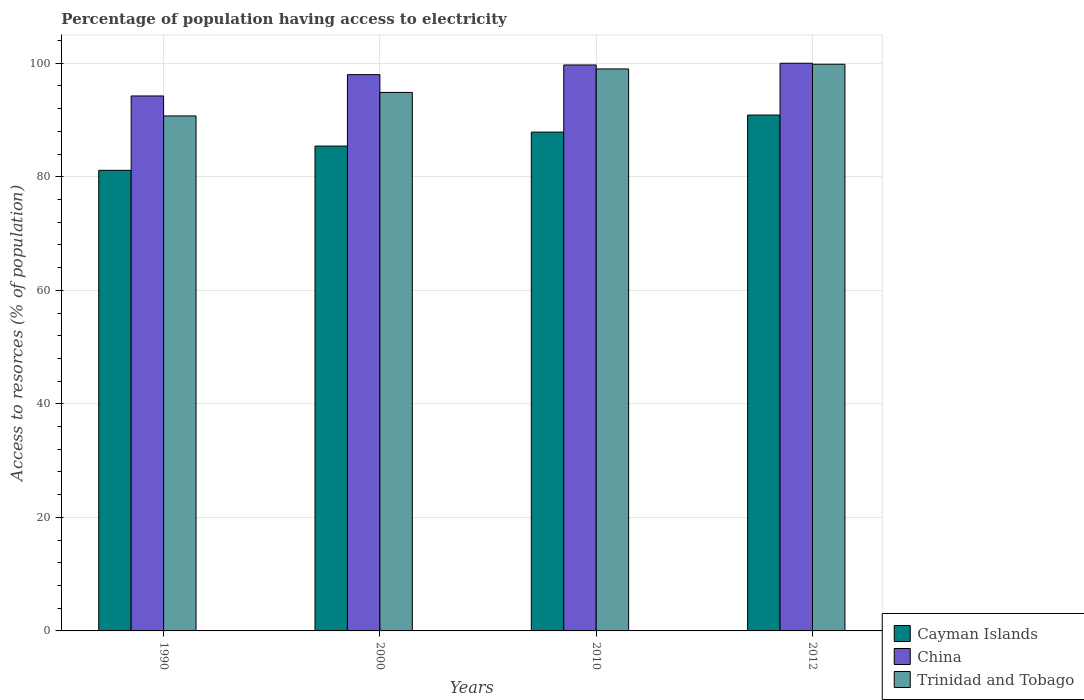How many different coloured bars are there?
Ensure brevity in your answer.  3. How many groups of bars are there?
Offer a terse response. 4. Are the number of bars per tick equal to the number of legend labels?
Provide a succinct answer. Yes. Are the number of bars on each tick of the X-axis equal?
Your response must be concise. Yes. How many bars are there on the 1st tick from the right?
Give a very brief answer. 3. In how many cases, is the number of bars for a given year not equal to the number of legend labels?
Offer a terse response. 0. What is the percentage of population having access to electricity in Cayman Islands in 2010?
Your answer should be very brief. 87.87. Across all years, what is the maximum percentage of population having access to electricity in Trinidad and Tobago?
Make the answer very short. 99.83. Across all years, what is the minimum percentage of population having access to electricity in Cayman Islands?
Provide a short and direct response. 81.14. In which year was the percentage of population having access to electricity in Cayman Islands maximum?
Offer a terse response. 2012. In which year was the percentage of population having access to electricity in Trinidad and Tobago minimum?
Make the answer very short. 1990. What is the total percentage of population having access to electricity in Trinidad and Tobago in the graph?
Your answer should be very brief. 384.41. What is the difference between the percentage of population having access to electricity in Trinidad and Tobago in 1990 and that in 2000?
Provide a succinct answer. -4.14. What is the difference between the percentage of population having access to electricity in Cayman Islands in 2010 and the percentage of population having access to electricity in Trinidad and Tobago in 1990?
Give a very brief answer. -2.85. What is the average percentage of population having access to electricity in China per year?
Your answer should be compact. 97.98. In the year 1990, what is the difference between the percentage of population having access to electricity in China and percentage of population having access to electricity in Cayman Islands?
Your response must be concise. 13.1. In how many years, is the percentage of population having access to electricity in Cayman Islands greater than 36 %?
Ensure brevity in your answer.  4. What is the ratio of the percentage of population having access to electricity in China in 1990 to that in 2000?
Provide a succinct answer. 0.96. What is the difference between the highest and the second highest percentage of population having access to electricity in China?
Ensure brevity in your answer.  0.3. What is the difference between the highest and the lowest percentage of population having access to electricity in Cayman Islands?
Keep it short and to the point. 9.74. Is the sum of the percentage of population having access to electricity in Trinidad and Tobago in 1990 and 2012 greater than the maximum percentage of population having access to electricity in China across all years?
Ensure brevity in your answer.  Yes. What does the 3rd bar from the left in 1990 represents?
Offer a very short reply. Trinidad and Tobago. What does the 2nd bar from the right in 1990 represents?
Provide a short and direct response. China. How many years are there in the graph?
Provide a short and direct response. 4. What is the title of the graph?
Provide a short and direct response. Percentage of population having access to electricity. What is the label or title of the X-axis?
Ensure brevity in your answer.  Years. What is the label or title of the Y-axis?
Your answer should be very brief. Access to resorces (% of population). What is the Access to resorces (% of population) in Cayman Islands in 1990?
Keep it short and to the point. 81.14. What is the Access to resorces (% of population) of China in 1990?
Offer a very short reply. 94.24. What is the Access to resorces (% of population) in Trinidad and Tobago in 1990?
Give a very brief answer. 90.72. What is the Access to resorces (% of population) in Cayman Islands in 2000?
Give a very brief answer. 85.41. What is the Access to resorces (% of population) of China in 2000?
Your answer should be compact. 98. What is the Access to resorces (% of population) of Trinidad and Tobago in 2000?
Your response must be concise. 94.86. What is the Access to resorces (% of population) of Cayman Islands in 2010?
Your response must be concise. 87.87. What is the Access to resorces (% of population) in China in 2010?
Make the answer very short. 99.7. What is the Access to resorces (% of population) of Cayman Islands in 2012?
Provide a short and direct response. 90.88. What is the Access to resorces (% of population) in Trinidad and Tobago in 2012?
Offer a very short reply. 99.83. Across all years, what is the maximum Access to resorces (% of population) in Cayman Islands?
Provide a succinct answer. 90.88. Across all years, what is the maximum Access to resorces (% of population) in China?
Offer a terse response. 100. Across all years, what is the maximum Access to resorces (% of population) of Trinidad and Tobago?
Offer a very short reply. 99.83. Across all years, what is the minimum Access to resorces (% of population) in Cayman Islands?
Your answer should be very brief. 81.14. Across all years, what is the minimum Access to resorces (% of population) in China?
Give a very brief answer. 94.24. Across all years, what is the minimum Access to resorces (% of population) of Trinidad and Tobago?
Your answer should be very brief. 90.72. What is the total Access to resorces (% of population) in Cayman Islands in the graph?
Provide a short and direct response. 345.3. What is the total Access to resorces (% of population) in China in the graph?
Offer a very short reply. 391.94. What is the total Access to resorces (% of population) in Trinidad and Tobago in the graph?
Offer a very short reply. 384.41. What is the difference between the Access to resorces (% of population) in Cayman Islands in 1990 and that in 2000?
Your answer should be compact. -4.28. What is the difference between the Access to resorces (% of population) in China in 1990 and that in 2000?
Your answer should be very brief. -3.76. What is the difference between the Access to resorces (% of population) in Trinidad and Tobago in 1990 and that in 2000?
Ensure brevity in your answer.  -4.14. What is the difference between the Access to resorces (% of population) in Cayman Islands in 1990 and that in 2010?
Keep it short and to the point. -6.74. What is the difference between the Access to resorces (% of population) of China in 1990 and that in 2010?
Your response must be concise. -5.46. What is the difference between the Access to resorces (% of population) of Trinidad and Tobago in 1990 and that in 2010?
Provide a short and direct response. -8.28. What is the difference between the Access to resorces (% of population) of Cayman Islands in 1990 and that in 2012?
Keep it short and to the point. -9.74. What is the difference between the Access to resorces (% of population) of China in 1990 and that in 2012?
Make the answer very short. -5.76. What is the difference between the Access to resorces (% of population) in Trinidad and Tobago in 1990 and that in 2012?
Offer a very short reply. -9.11. What is the difference between the Access to resorces (% of population) of Cayman Islands in 2000 and that in 2010?
Provide a succinct answer. -2.46. What is the difference between the Access to resorces (% of population) in China in 2000 and that in 2010?
Make the answer very short. -1.7. What is the difference between the Access to resorces (% of population) in Trinidad and Tobago in 2000 and that in 2010?
Give a very brief answer. -4.14. What is the difference between the Access to resorces (% of population) in Cayman Islands in 2000 and that in 2012?
Provide a succinct answer. -5.46. What is the difference between the Access to resorces (% of population) in Trinidad and Tobago in 2000 and that in 2012?
Offer a terse response. -4.97. What is the difference between the Access to resorces (% of population) of Cayman Islands in 2010 and that in 2012?
Make the answer very short. -3. What is the difference between the Access to resorces (% of population) in China in 2010 and that in 2012?
Your response must be concise. -0.3. What is the difference between the Access to resorces (% of population) in Trinidad and Tobago in 2010 and that in 2012?
Keep it short and to the point. -0.83. What is the difference between the Access to resorces (% of population) in Cayman Islands in 1990 and the Access to resorces (% of population) in China in 2000?
Offer a very short reply. -16.86. What is the difference between the Access to resorces (% of population) of Cayman Islands in 1990 and the Access to resorces (% of population) of Trinidad and Tobago in 2000?
Your response must be concise. -13.73. What is the difference between the Access to resorces (% of population) of China in 1990 and the Access to resorces (% of population) of Trinidad and Tobago in 2000?
Provide a short and direct response. -0.62. What is the difference between the Access to resorces (% of population) of Cayman Islands in 1990 and the Access to resorces (% of population) of China in 2010?
Provide a short and direct response. -18.56. What is the difference between the Access to resorces (% of population) of Cayman Islands in 1990 and the Access to resorces (% of population) of Trinidad and Tobago in 2010?
Give a very brief answer. -17.86. What is the difference between the Access to resorces (% of population) of China in 1990 and the Access to resorces (% of population) of Trinidad and Tobago in 2010?
Offer a terse response. -4.76. What is the difference between the Access to resorces (% of population) in Cayman Islands in 1990 and the Access to resorces (% of population) in China in 2012?
Your response must be concise. -18.86. What is the difference between the Access to resorces (% of population) in Cayman Islands in 1990 and the Access to resorces (% of population) in Trinidad and Tobago in 2012?
Provide a short and direct response. -18.69. What is the difference between the Access to resorces (% of population) in China in 1990 and the Access to resorces (% of population) in Trinidad and Tobago in 2012?
Make the answer very short. -5.59. What is the difference between the Access to resorces (% of population) of Cayman Islands in 2000 and the Access to resorces (% of population) of China in 2010?
Your answer should be compact. -14.29. What is the difference between the Access to resorces (% of population) in Cayman Islands in 2000 and the Access to resorces (% of population) in Trinidad and Tobago in 2010?
Offer a terse response. -13.59. What is the difference between the Access to resorces (% of population) of Cayman Islands in 2000 and the Access to resorces (% of population) of China in 2012?
Your response must be concise. -14.59. What is the difference between the Access to resorces (% of population) in Cayman Islands in 2000 and the Access to resorces (% of population) in Trinidad and Tobago in 2012?
Your answer should be compact. -14.42. What is the difference between the Access to resorces (% of population) in China in 2000 and the Access to resorces (% of population) in Trinidad and Tobago in 2012?
Make the answer very short. -1.83. What is the difference between the Access to resorces (% of population) of Cayman Islands in 2010 and the Access to resorces (% of population) of China in 2012?
Your answer should be very brief. -12.13. What is the difference between the Access to resorces (% of population) of Cayman Islands in 2010 and the Access to resorces (% of population) of Trinidad and Tobago in 2012?
Offer a very short reply. -11.95. What is the difference between the Access to resorces (% of population) of China in 2010 and the Access to resorces (% of population) of Trinidad and Tobago in 2012?
Make the answer very short. -0.13. What is the average Access to resorces (% of population) of Cayman Islands per year?
Provide a succinct answer. 86.32. What is the average Access to resorces (% of population) of China per year?
Your response must be concise. 97.98. What is the average Access to resorces (% of population) in Trinidad and Tobago per year?
Your answer should be compact. 96.1. In the year 1990, what is the difference between the Access to resorces (% of population) in Cayman Islands and Access to resorces (% of population) in China?
Keep it short and to the point. -13.1. In the year 1990, what is the difference between the Access to resorces (% of population) in Cayman Islands and Access to resorces (% of population) in Trinidad and Tobago?
Provide a succinct answer. -9.59. In the year 1990, what is the difference between the Access to resorces (% of population) in China and Access to resorces (% of population) in Trinidad and Tobago?
Keep it short and to the point. 3.52. In the year 2000, what is the difference between the Access to resorces (% of population) of Cayman Islands and Access to resorces (% of population) of China?
Offer a terse response. -12.59. In the year 2000, what is the difference between the Access to resorces (% of population) of Cayman Islands and Access to resorces (% of population) of Trinidad and Tobago?
Your answer should be very brief. -9.45. In the year 2000, what is the difference between the Access to resorces (% of population) of China and Access to resorces (% of population) of Trinidad and Tobago?
Offer a very short reply. 3.14. In the year 2010, what is the difference between the Access to resorces (% of population) of Cayman Islands and Access to resorces (% of population) of China?
Ensure brevity in your answer.  -11.83. In the year 2010, what is the difference between the Access to resorces (% of population) of Cayman Islands and Access to resorces (% of population) of Trinidad and Tobago?
Your answer should be compact. -11.13. In the year 2010, what is the difference between the Access to resorces (% of population) in China and Access to resorces (% of population) in Trinidad and Tobago?
Your answer should be very brief. 0.7. In the year 2012, what is the difference between the Access to resorces (% of population) in Cayman Islands and Access to resorces (% of population) in China?
Keep it short and to the point. -9.12. In the year 2012, what is the difference between the Access to resorces (% of population) in Cayman Islands and Access to resorces (% of population) in Trinidad and Tobago?
Offer a very short reply. -8.95. In the year 2012, what is the difference between the Access to resorces (% of population) in China and Access to resorces (% of population) in Trinidad and Tobago?
Give a very brief answer. 0.17. What is the ratio of the Access to resorces (% of population) of Cayman Islands in 1990 to that in 2000?
Your answer should be compact. 0.95. What is the ratio of the Access to resorces (% of population) in China in 1990 to that in 2000?
Your answer should be compact. 0.96. What is the ratio of the Access to resorces (% of population) in Trinidad and Tobago in 1990 to that in 2000?
Offer a very short reply. 0.96. What is the ratio of the Access to resorces (% of population) in Cayman Islands in 1990 to that in 2010?
Keep it short and to the point. 0.92. What is the ratio of the Access to resorces (% of population) of China in 1990 to that in 2010?
Provide a succinct answer. 0.95. What is the ratio of the Access to resorces (% of population) in Trinidad and Tobago in 1990 to that in 2010?
Make the answer very short. 0.92. What is the ratio of the Access to resorces (% of population) of Cayman Islands in 1990 to that in 2012?
Your answer should be very brief. 0.89. What is the ratio of the Access to resorces (% of population) of China in 1990 to that in 2012?
Offer a very short reply. 0.94. What is the ratio of the Access to resorces (% of population) in Trinidad and Tobago in 1990 to that in 2012?
Your answer should be very brief. 0.91. What is the ratio of the Access to resorces (% of population) in China in 2000 to that in 2010?
Ensure brevity in your answer.  0.98. What is the ratio of the Access to resorces (% of population) of Trinidad and Tobago in 2000 to that in 2010?
Give a very brief answer. 0.96. What is the ratio of the Access to resorces (% of population) in Cayman Islands in 2000 to that in 2012?
Make the answer very short. 0.94. What is the ratio of the Access to resorces (% of population) of China in 2000 to that in 2012?
Offer a terse response. 0.98. What is the ratio of the Access to resorces (% of population) in Trinidad and Tobago in 2000 to that in 2012?
Provide a succinct answer. 0.95. What is the ratio of the Access to resorces (% of population) of Cayman Islands in 2010 to that in 2012?
Your response must be concise. 0.97. What is the ratio of the Access to resorces (% of population) of Trinidad and Tobago in 2010 to that in 2012?
Provide a short and direct response. 0.99. What is the difference between the highest and the second highest Access to resorces (% of population) of Cayman Islands?
Provide a succinct answer. 3. What is the difference between the highest and the second highest Access to resorces (% of population) in China?
Keep it short and to the point. 0.3. What is the difference between the highest and the second highest Access to resorces (% of population) of Trinidad and Tobago?
Make the answer very short. 0.83. What is the difference between the highest and the lowest Access to resorces (% of population) of Cayman Islands?
Your response must be concise. 9.74. What is the difference between the highest and the lowest Access to resorces (% of population) of China?
Provide a succinct answer. 5.76. What is the difference between the highest and the lowest Access to resorces (% of population) of Trinidad and Tobago?
Offer a terse response. 9.11. 